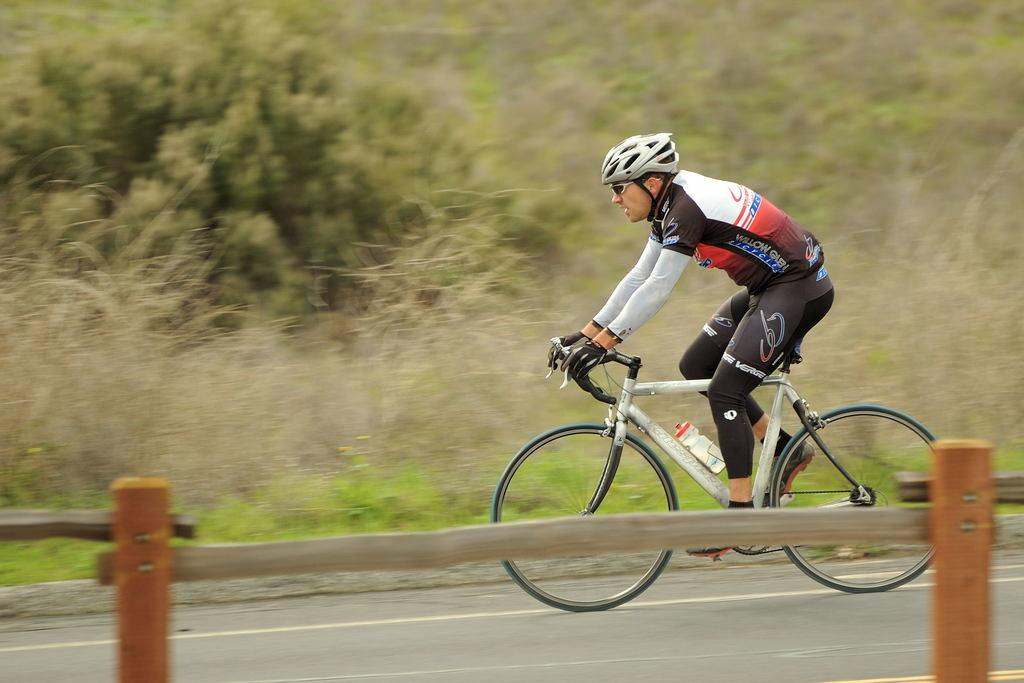What is the person in the image doing? The person in the image is riding a bicycle. What safety equipment is the person wearing? The person is wearing a helmet, goggles, gloves, and shoes. What can be seen in the background of the image? There are trees in the background of the image. What type of calculator is the person using while riding the bicycle? There is no calculator present in the image, and the person is not using one while riding the bicycle. 